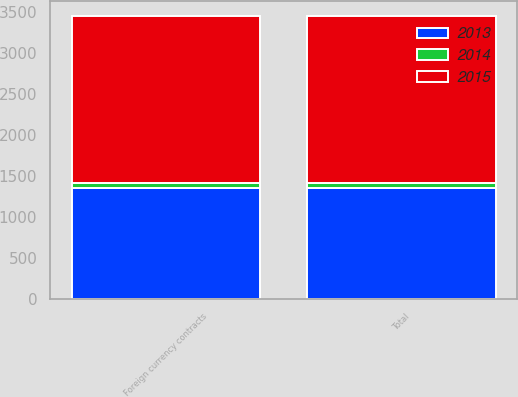Convert chart. <chart><loc_0><loc_0><loc_500><loc_500><stacked_bar_chart><ecel><fcel>Foreign currency contracts<fcel>Total<nl><fcel>2013<fcel>1347<fcel>1347<nl><fcel>2015<fcel>2047<fcel>2047<nl><fcel>2014<fcel>61<fcel>61<nl></chart> 